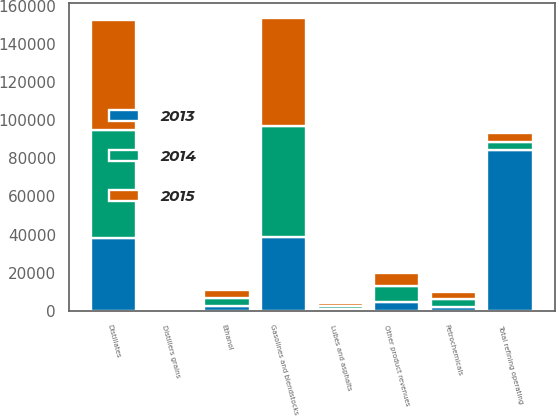Convert chart to OTSL. <chart><loc_0><loc_0><loc_500><loc_500><stacked_bar_chart><ecel><fcel>Gasolines and blendstocks<fcel>Distillates<fcel>Petrochemicals<fcel>Lubes and asphalts<fcel>Other product revenues<fcel>Total refining operating<fcel>Ethanol<fcel>Distillers grains<nl><fcel>2013<fcel>38983<fcel>38093<fcel>1824<fcel>874<fcel>4747<fcel>84521<fcel>2628<fcel>655<nl><fcel>2015<fcel>56846<fcel>57521<fcel>3759<fcel>1397<fcel>6481<fcel>4263<fcel>4192<fcel>648<nl><fcel>2014<fcel>57806<fcel>56921<fcel>4281<fcel>1643<fcel>8413<fcel>4263<fcel>4245<fcel>869<nl></chart> 